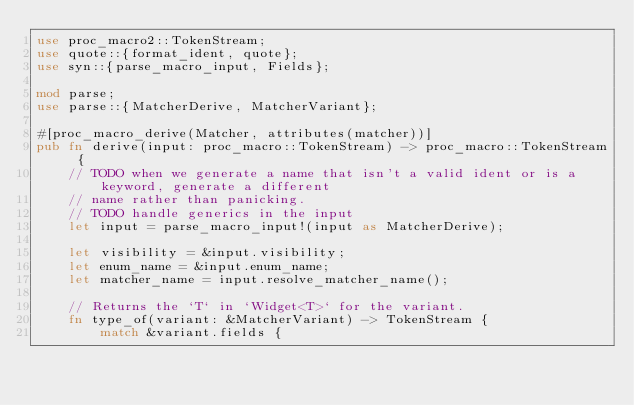Convert code to text. <code><loc_0><loc_0><loc_500><loc_500><_Rust_>use proc_macro2::TokenStream;
use quote::{format_ident, quote};
use syn::{parse_macro_input, Fields};

mod parse;
use parse::{MatcherDerive, MatcherVariant};

#[proc_macro_derive(Matcher, attributes(matcher))]
pub fn derive(input: proc_macro::TokenStream) -> proc_macro::TokenStream {
    // TODO when we generate a name that isn't a valid ident or is a keyword, generate a different
    // name rather than panicking.
    // TODO handle generics in the input
    let input = parse_macro_input!(input as MatcherDerive);

    let visibility = &input.visibility;
    let enum_name = &input.enum_name;
    let matcher_name = input.resolve_matcher_name();

    // Returns the `T` in `Widget<T>` for the variant.
    fn type_of(variant: &MatcherVariant) -> TokenStream {
        match &variant.fields {</code> 